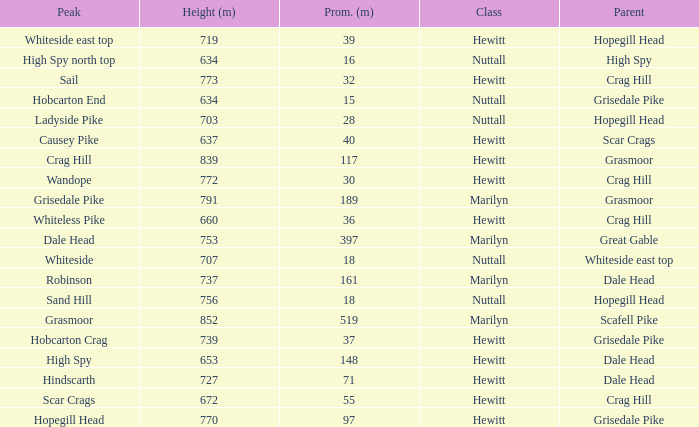What is the lowest height for Parent grasmoor when it has a Prom larger than 117? 791.0. 